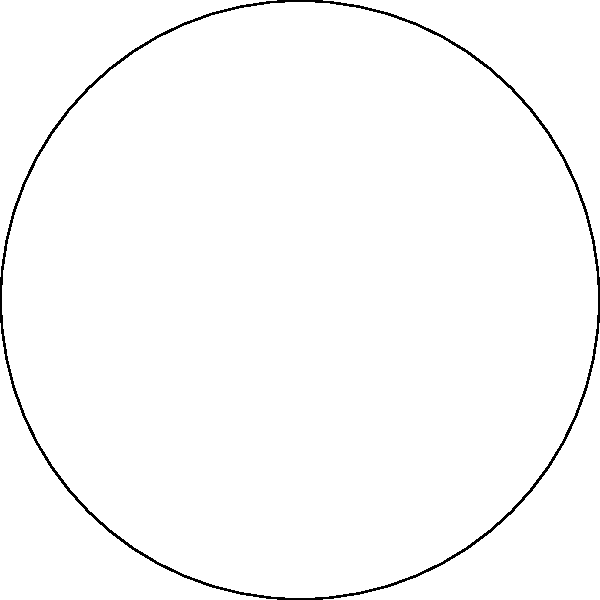In a top-down game view, you want to create a fan-shaped area of effect (AOE) spell. The spell originates from the player's position (point O) and extends outward with a maximum range of 3 units. If the spell's arc covers an angle of 60°, what fraction of the total circular area does this fan-shaped AOE represent? To solve this problem, let's follow these steps:

1. Understand the given information:
   - The spell's maximum range is 3 units (radius of the circle)
   - The angle of the fan-shaped area is 60°

2. Recall the formula for the area of a sector (fan-shaped area):
   $A_{sector} = \frac{\theta}{360°} \pi r^2$
   Where $\theta$ is the central angle in degrees, and $r$ is the radius.

3. Calculate the area of the fan-shaped AOE:
   $A_{fan} = \frac{60°}{360°} \pi (3)^2 = \frac{1}{6} \pi (9) = \frac{3\pi}{2}$ square units

4. Calculate the total area of the circle:
   $A_{circle} = \pi r^2 = \pi (3)^2 = 9\pi$ square units

5. Find the fraction of the total area that the fan-shaped AOE represents:
   $\frac{A_{fan}}{A_{circle}} = \frac{3\pi/2}{9\pi} = \frac{1}{6}$

Therefore, the fan-shaped AOE represents 1/6 of the total circular area.
Answer: $\frac{1}{6}$ 